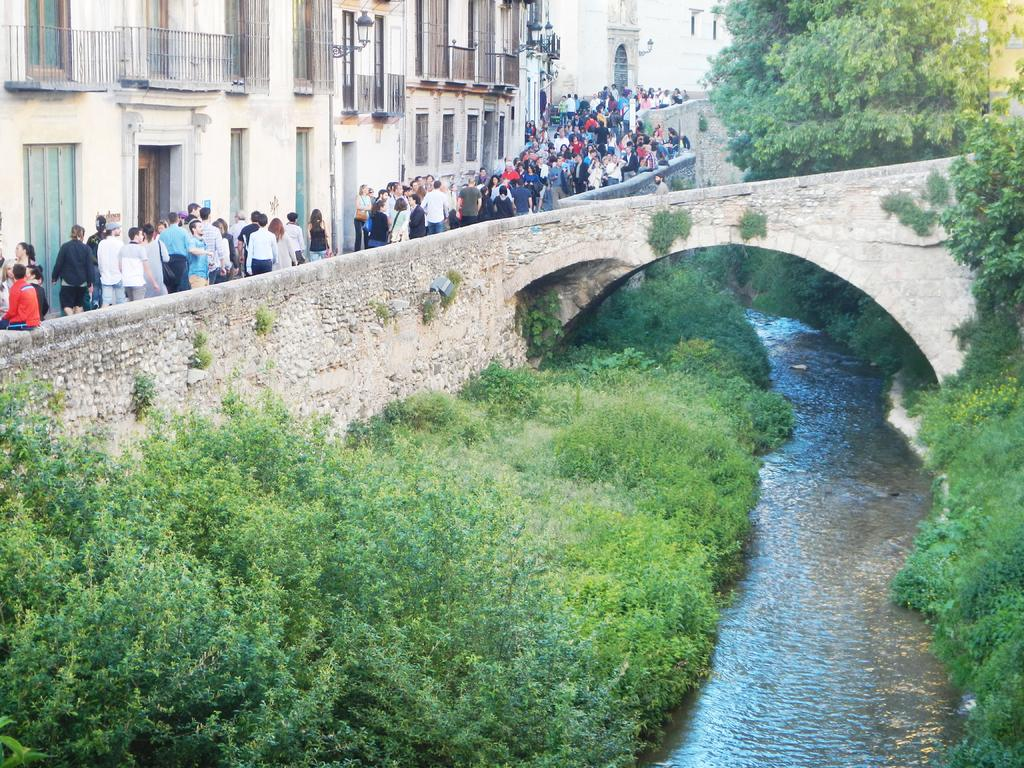How many people are in the image? There are people in the image, but the exact number is not specified. What type of structure can be seen in the image? There is a building in the image. What architectural feature is present in the image? There is a bridge in the image. What type of vegetation is visible in the image? There are plants and trees in the image. What natural element is present in the image? There is water visible in the image. How many chickens are sitting on the bridge in the image? There are no chickens present in the image. What type of bit is being used by the people in the image? There is no mention of any bit being used by the people in the image. 